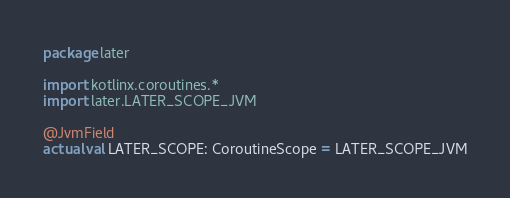Convert code to text. <code><loc_0><loc_0><loc_500><loc_500><_Kotlin_>package later

import kotlinx.coroutines.*
import later.LATER_SCOPE_JVM

@JvmField
actual val LATER_SCOPE: CoroutineScope = LATER_SCOPE_JVM</code> 